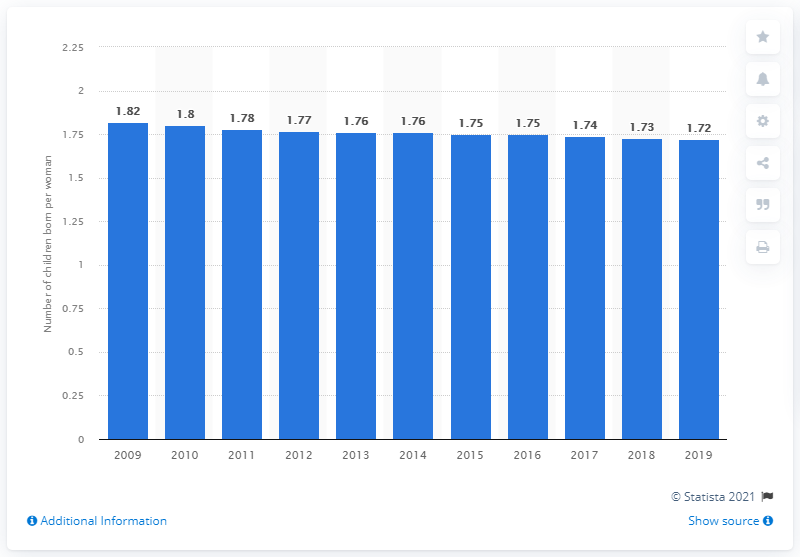Outline some significant characteristics in this image. The fertility rate in Brazil in 2019 was 1.72 children per woman. 